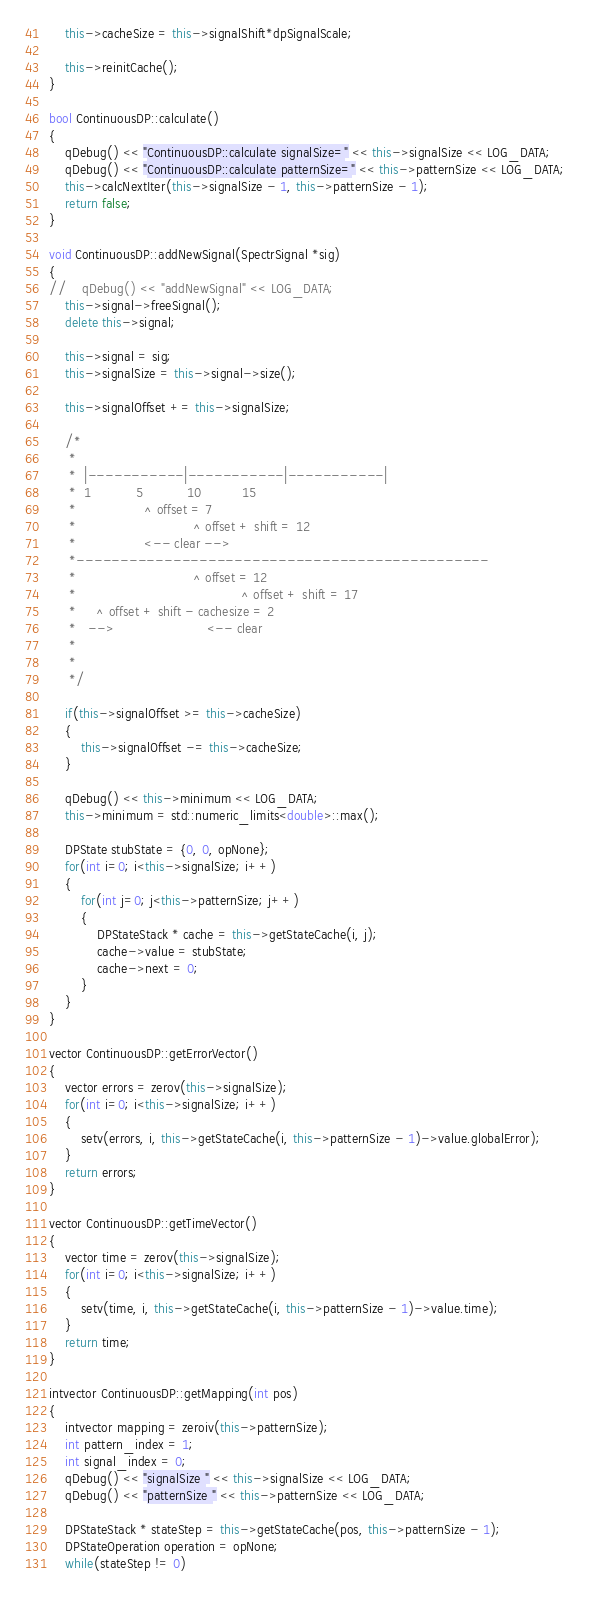Convert code to text. <code><loc_0><loc_0><loc_500><loc_500><_C++_>    this->cacheSize = this->signalShift*dpSignalScale;

    this->reinitCache();
}

bool ContinuousDP::calculate()
{
    qDebug() << "ContinuousDP::calculate signalSize=" << this->signalSize << LOG_DATA;
    qDebug() << "ContinuousDP::calculate patternSize=" << this->patternSize << LOG_DATA;
    this->calcNextIter(this->signalSize - 1, this->patternSize - 1);
    return false;
}

void ContinuousDP::addNewSignal(SpectrSignal *sig)
{
//    qDebug() << "addNewSignal" << LOG_DATA;
    this->signal->freeSignal();
    delete this->signal;

    this->signal = sig;
    this->signalSize = this->signal->size();

    this->signalOffset += this->signalSize;

    /*
     *
     *  |-----------|-----------|-----------|
     *  1           5           10          15
     *                 ^ offset = 7
     *                             ^ offset + shift = 12
     *                 <-- clear -->
     *-----------------------------------------------
     *                             ^ offset = 12
     *                                         ^ offset + shift = 17
     *     ^ offset + shift - cachesize = 2
     *   -->                       <-- clear
     *
     *
     */

    if(this->signalOffset >= this->cacheSize)
    {
        this->signalOffset -= this->cacheSize;
    }

    qDebug() << this->minimum << LOG_DATA;
    this->minimum = std::numeric_limits<double>::max();

    DPState stubState = {0, 0, opNone};
    for(int i=0; i<this->signalSize; i++)
    {
        for(int j=0; j<this->patternSize; j++)
        {
            DPStateStack * cache = this->getStateCache(i, j);
            cache->value = stubState;
            cache->next = 0;
        }
    }
}

vector ContinuousDP::getErrorVector()
{
    vector errors = zerov(this->signalSize);
    for(int i=0; i<this->signalSize; i++)
    {
        setv(errors, i, this->getStateCache(i, this->patternSize - 1)->value.globalError);
    }
    return errors;
}

vector ContinuousDP::getTimeVector()
{
    vector time = zerov(this->signalSize);
    for(int i=0; i<this->signalSize; i++)
    {
        setv(time, i, this->getStateCache(i, this->patternSize - 1)->value.time);
    }
    return time;
}

intvector ContinuousDP::getMapping(int pos)
{
    intvector mapping = zeroiv(this->patternSize);
    int pattern_index = 1;
    int signal_index = 0;
    qDebug() << "signalSize " << this->signalSize << LOG_DATA;
    qDebug() << "patternSize " << this->patternSize << LOG_DATA;

    DPStateStack * stateStep = this->getStateCache(pos, this->patternSize - 1);
    DPStateOperation operation = opNone;
    while(stateStep != 0)</code> 